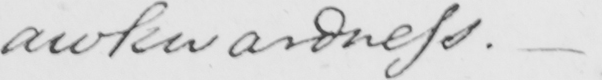What does this handwritten line say? awkwardness .  _ 